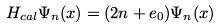<formula> <loc_0><loc_0><loc_500><loc_500>H _ { c a l } \Psi _ { n } ( x ) = ( 2 n + e _ { 0 } ) \Psi _ { n } ( x )</formula> 